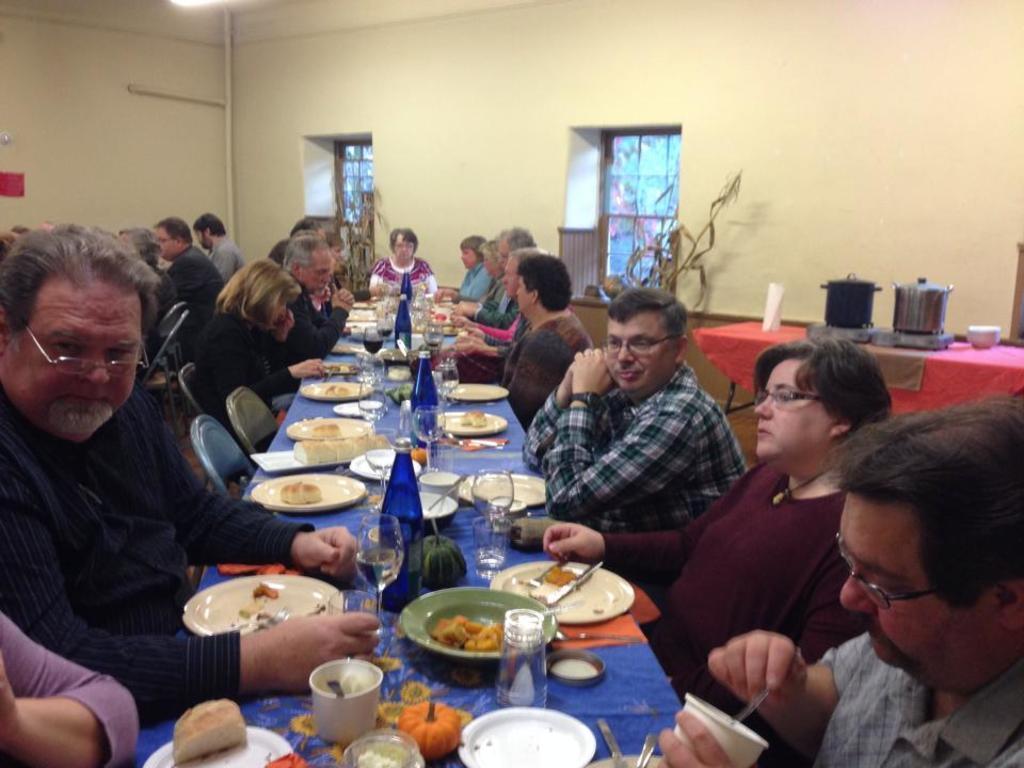Could you give a brief overview of what you see in this image? In this image i can see few persons sitting on a chair there are few plates and bottles on a table at the back ground there a wall. 